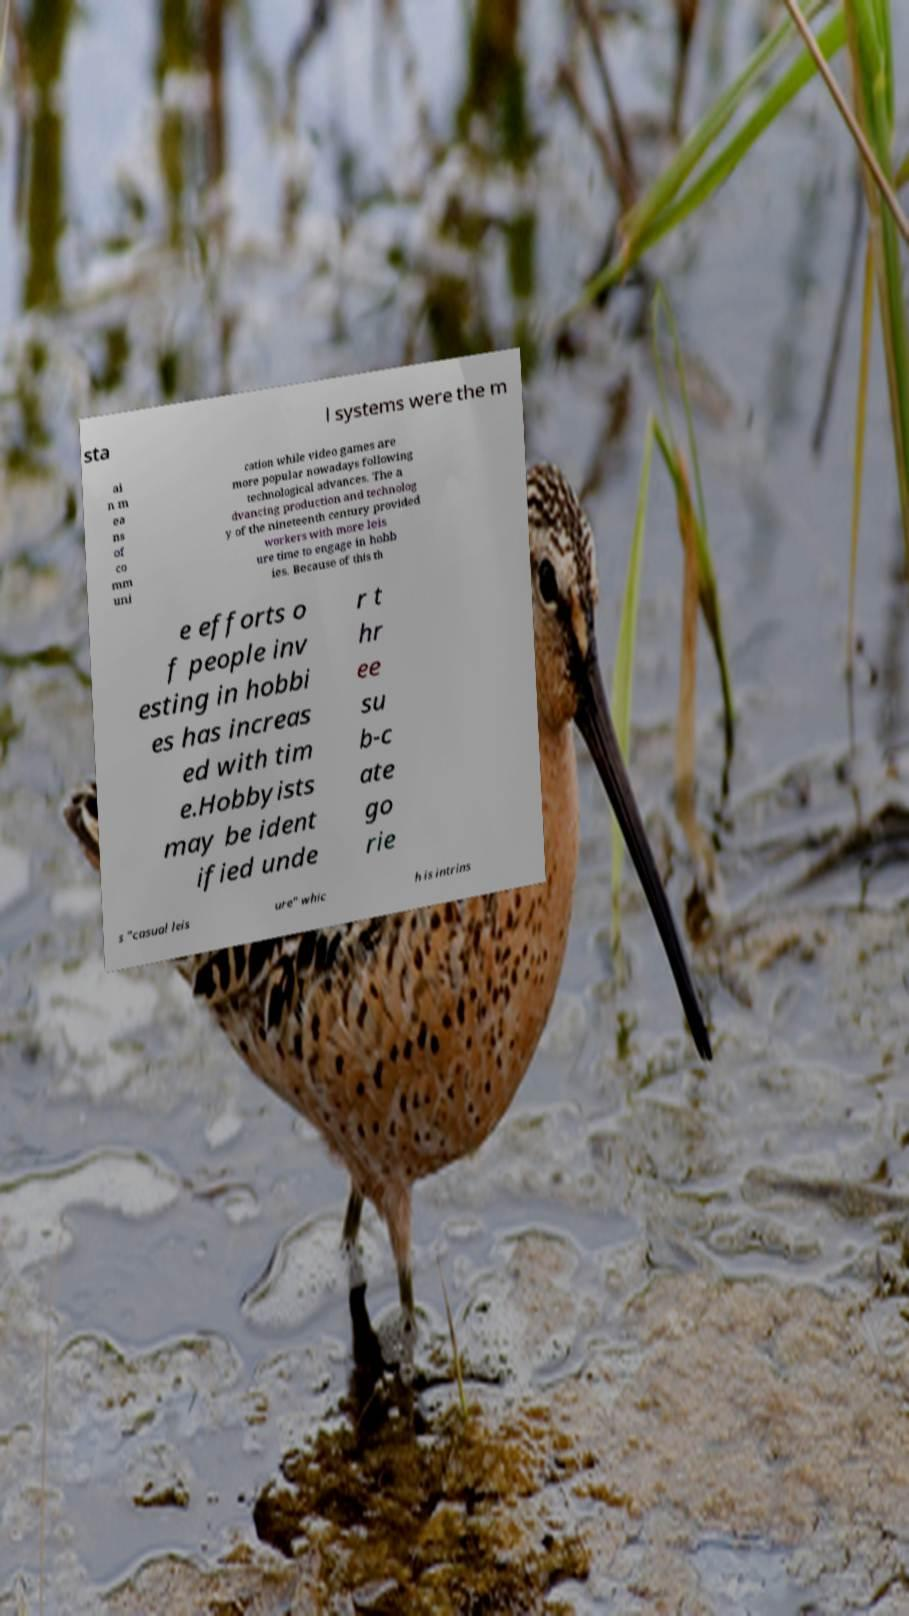Can you accurately transcribe the text from the provided image for me? sta l systems were the m ai n m ea ns of co mm uni cation while video games are more popular nowadays following technological advances. The a dvancing production and technolog y of the nineteenth century provided workers with more leis ure time to engage in hobb ies. Because of this th e efforts o f people inv esting in hobbi es has increas ed with tim e.Hobbyists may be ident ified unde r t hr ee su b-c ate go rie s "casual leis ure" whic h is intrins 